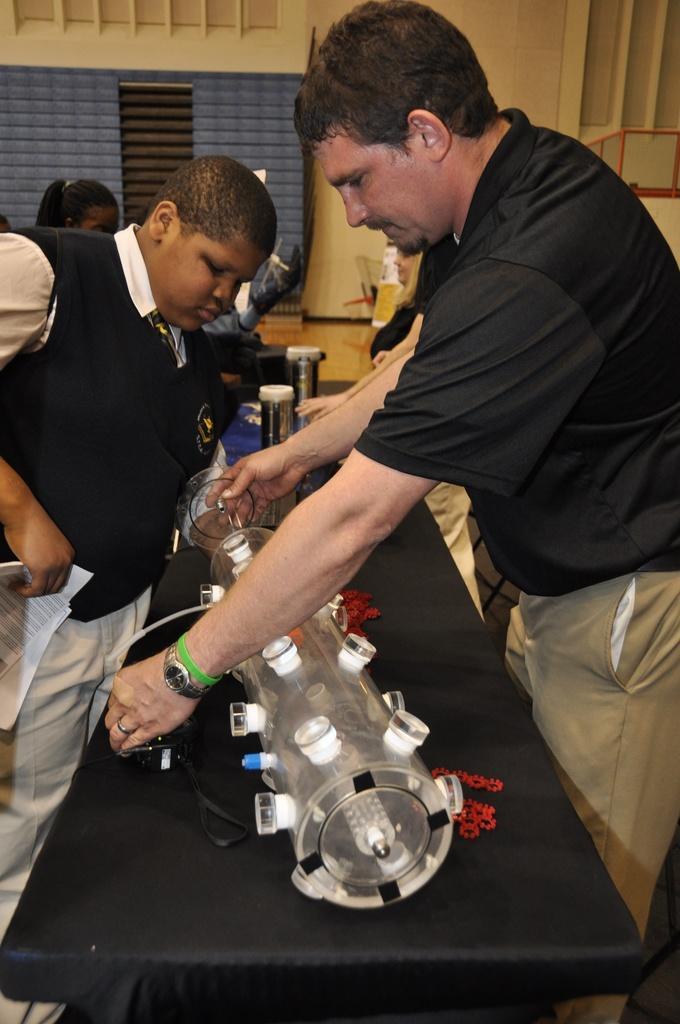Describe this image in one or two sentences. In this picture we can see a group of people,here we can see some objects. 